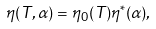Convert formula to latex. <formula><loc_0><loc_0><loc_500><loc_500>\eta ( T , \alpha ) = \eta _ { 0 } ( T ) \eta ^ { * } ( \alpha ) ,</formula> 